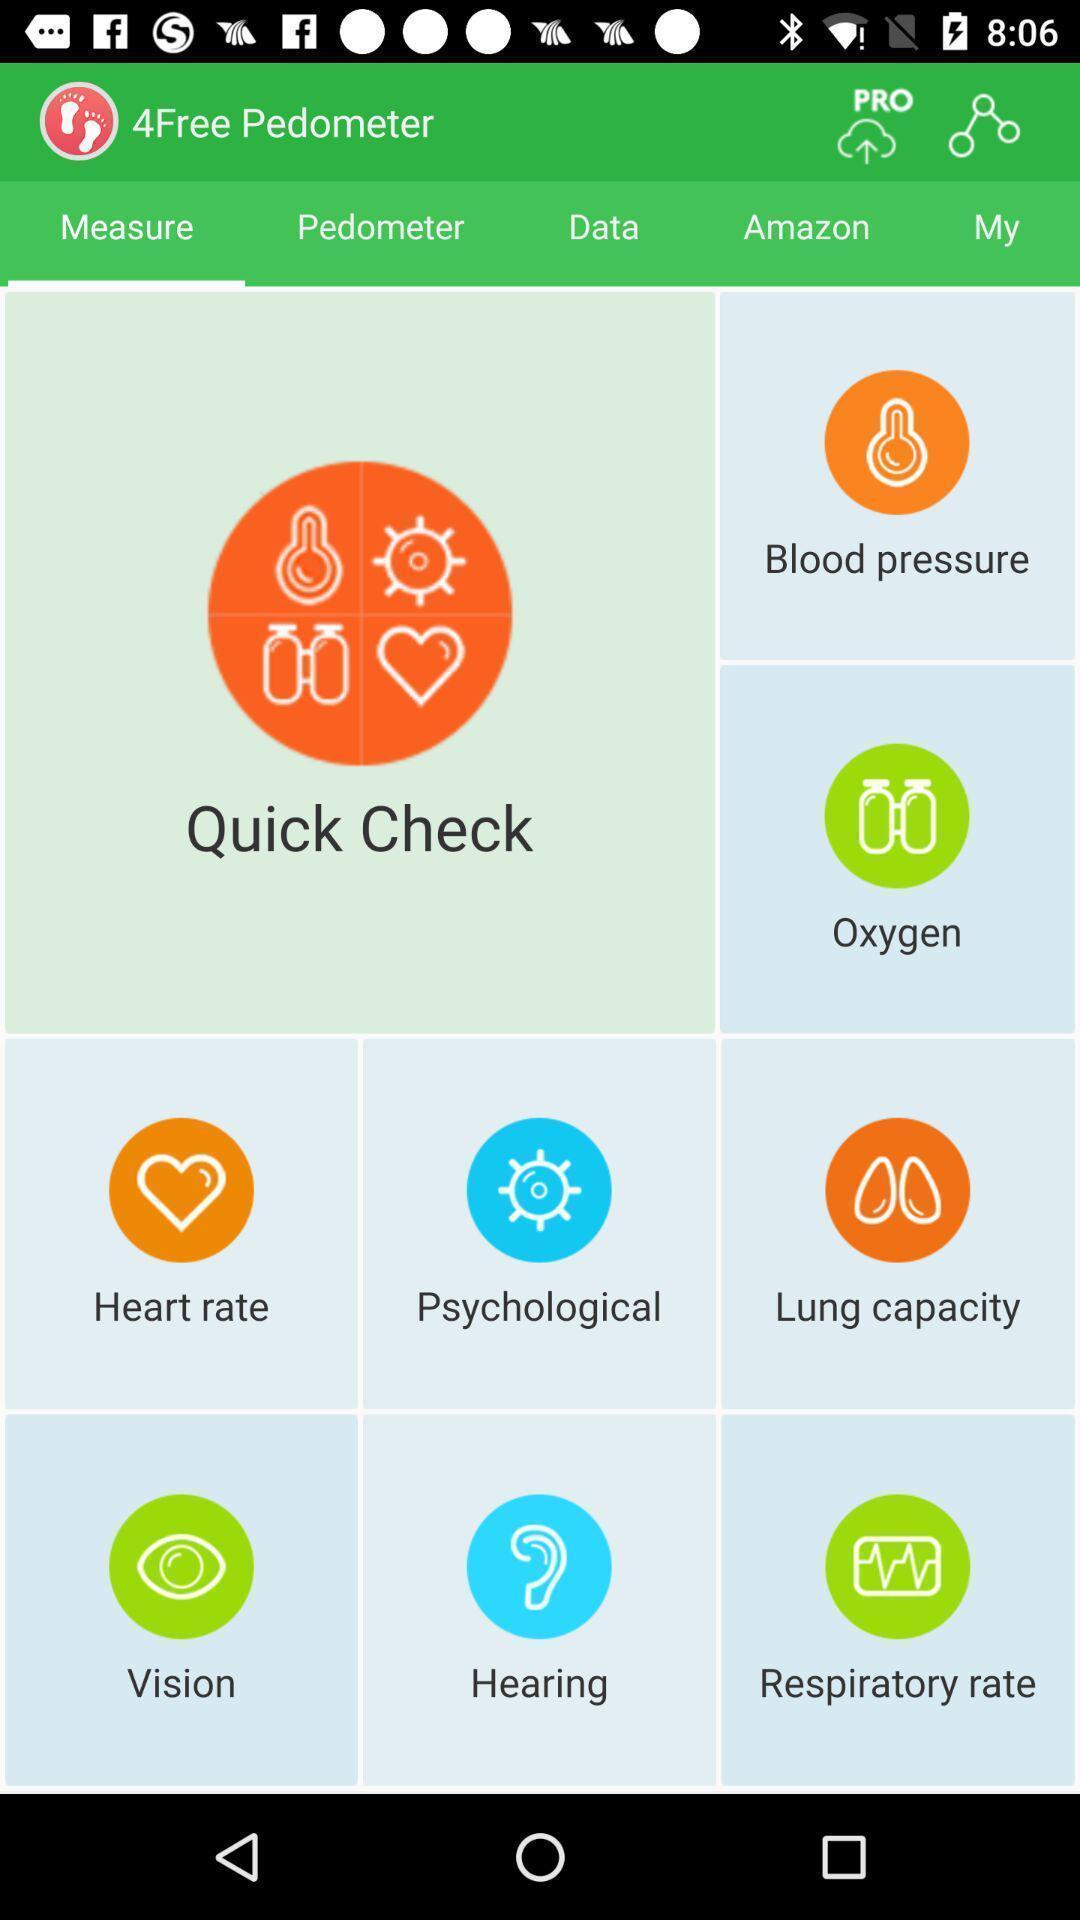Provide a detailed account of this screenshot. Screen displaying multiple options with icons and names. 